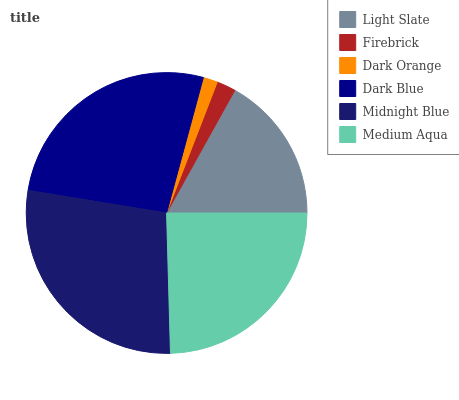Is Dark Orange the minimum?
Answer yes or no. Yes. Is Midnight Blue the maximum?
Answer yes or no. Yes. Is Firebrick the minimum?
Answer yes or no. No. Is Firebrick the maximum?
Answer yes or no. No. Is Light Slate greater than Firebrick?
Answer yes or no. Yes. Is Firebrick less than Light Slate?
Answer yes or no. Yes. Is Firebrick greater than Light Slate?
Answer yes or no. No. Is Light Slate less than Firebrick?
Answer yes or no. No. Is Medium Aqua the high median?
Answer yes or no. Yes. Is Light Slate the low median?
Answer yes or no. Yes. Is Light Slate the high median?
Answer yes or no. No. Is Midnight Blue the low median?
Answer yes or no. No. 